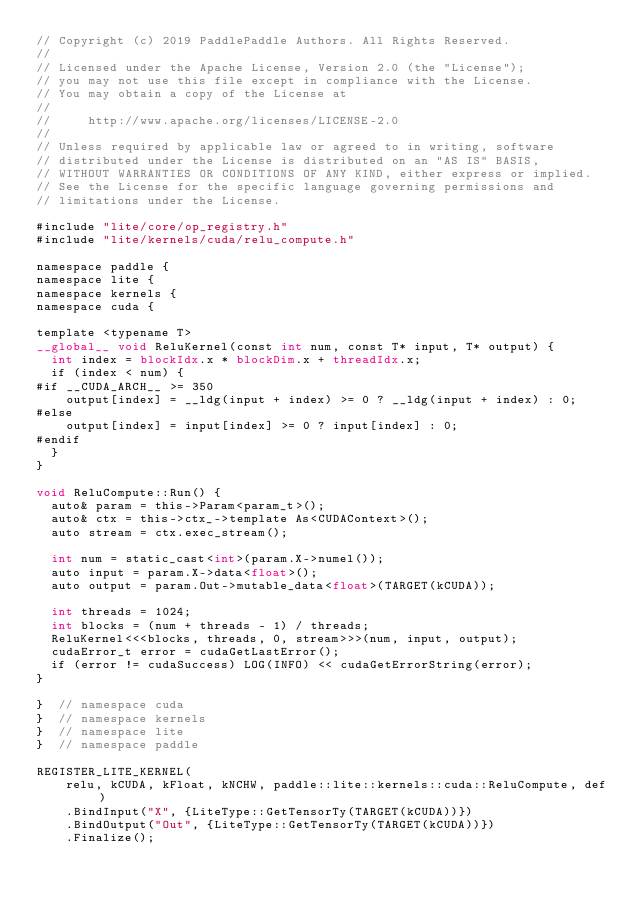<code> <loc_0><loc_0><loc_500><loc_500><_Cuda_>// Copyright (c) 2019 PaddlePaddle Authors. All Rights Reserved.
//
// Licensed under the Apache License, Version 2.0 (the "License");
// you may not use this file except in compliance with the License.
// You may obtain a copy of the License at
//
//     http://www.apache.org/licenses/LICENSE-2.0
//
// Unless required by applicable law or agreed to in writing, software
// distributed under the License is distributed on an "AS IS" BASIS,
// WITHOUT WARRANTIES OR CONDITIONS OF ANY KIND, either express or implied.
// See the License for the specific language governing permissions and
// limitations under the License.

#include "lite/core/op_registry.h"
#include "lite/kernels/cuda/relu_compute.h"

namespace paddle {
namespace lite {
namespace kernels {
namespace cuda {

template <typename T>
__global__ void ReluKernel(const int num, const T* input, T* output) {
  int index = blockIdx.x * blockDim.x + threadIdx.x;
  if (index < num) {
#if __CUDA_ARCH__ >= 350
    output[index] = __ldg(input + index) >= 0 ? __ldg(input + index) : 0;
#else
    output[index] = input[index] >= 0 ? input[index] : 0;
#endif
  }
}

void ReluCompute::Run() {
  auto& param = this->Param<param_t>();
  auto& ctx = this->ctx_->template As<CUDAContext>();
  auto stream = ctx.exec_stream();

  int num = static_cast<int>(param.X->numel());
  auto input = param.X->data<float>();
  auto output = param.Out->mutable_data<float>(TARGET(kCUDA));

  int threads = 1024;
  int blocks = (num + threads - 1) / threads;
  ReluKernel<<<blocks, threads, 0, stream>>>(num, input, output);
  cudaError_t error = cudaGetLastError();
  if (error != cudaSuccess) LOG(INFO) << cudaGetErrorString(error);
}

}  // namespace cuda
}  // namespace kernels
}  // namespace lite
}  // namespace paddle

REGISTER_LITE_KERNEL(
    relu, kCUDA, kFloat, kNCHW, paddle::lite::kernels::cuda::ReluCompute, def)
    .BindInput("X", {LiteType::GetTensorTy(TARGET(kCUDA))})
    .BindOutput("Out", {LiteType::GetTensorTy(TARGET(kCUDA))})
    .Finalize();
</code> 